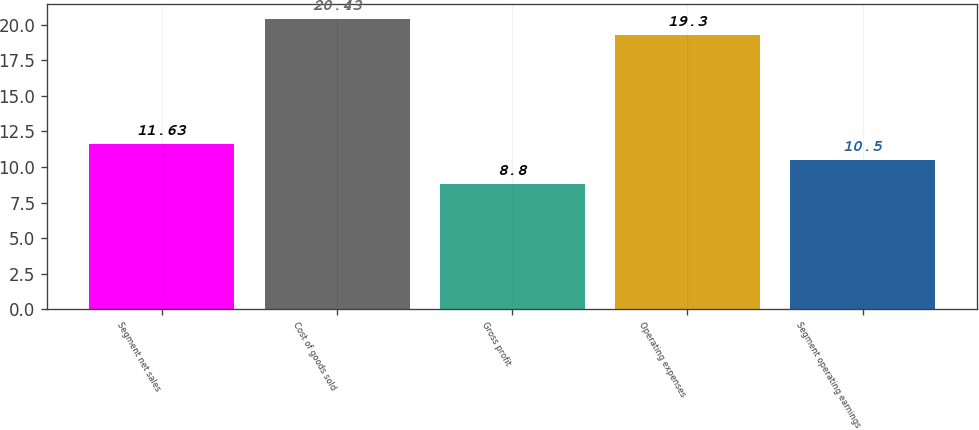<chart> <loc_0><loc_0><loc_500><loc_500><bar_chart><fcel>Segment net sales<fcel>Cost of goods sold<fcel>Gross profit<fcel>Operating expenses<fcel>Segment operating earnings<nl><fcel>11.63<fcel>20.43<fcel>8.8<fcel>19.3<fcel>10.5<nl></chart> 